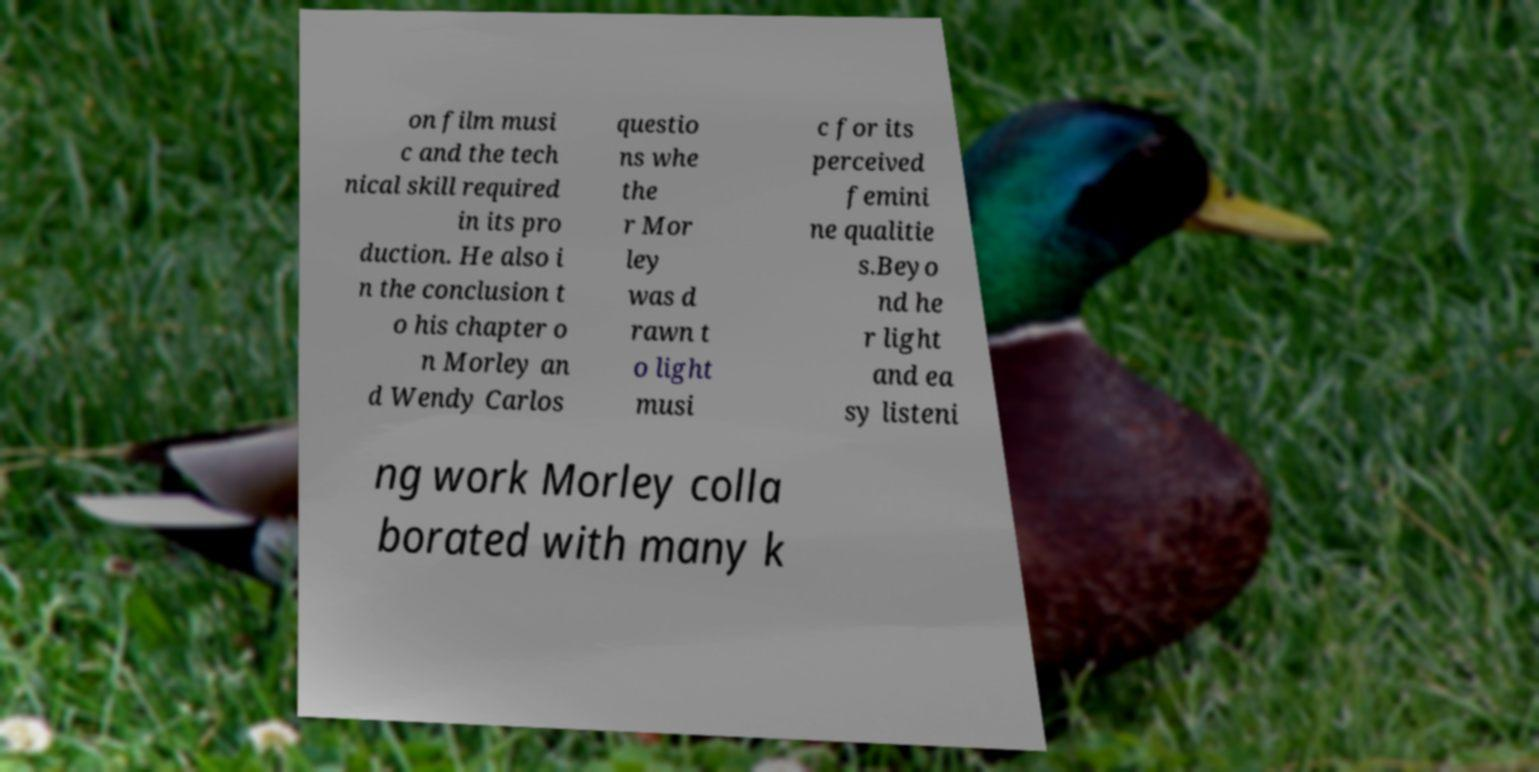Can you accurately transcribe the text from the provided image for me? on film musi c and the tech nical skill required in its pro duction. He also i n the conclusion t o his chapter o n Morley an d Wendy Carlos questio ns whe the r Mor ley was d rawn t o light musi c for its perceived femini ne qualitie s.Beyo nd he r light and ea sy listeni ng work Morley colla borated with many k 